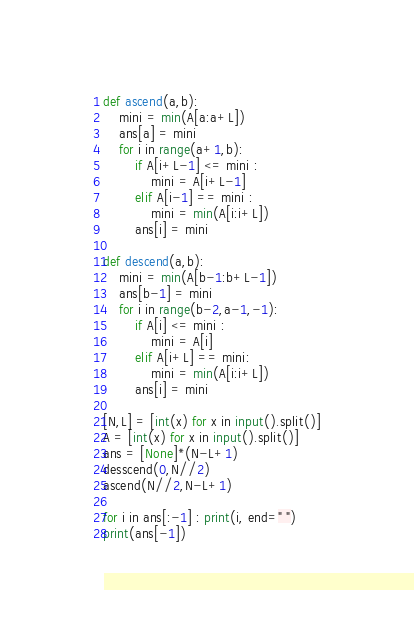<code> <loc_0><loc_0><loc_500><loc_500><_Python_>def ascend(a,b):
    mini = min(A[a:a+L])
    ans[a] = mini
    for i in range(a+1,b):
        if A[i+L-1] <= mini :
            mini = A[i+L-1]
        elif A[i-1] == mini :
            mini = min(A[i:i+L])
        ans[i] = mini

def descend(a,b):
    mini = min(A[b-1:b+L-1])
    ans[b-1] = mini
    for i in range(b-2,a-1,-1):
        if A[i] <= mini :
            mini = A[i]
        elif A[i+L] == mini:
            mini = min(A[i:i+L])
        ans[i] = mini
    
[N,L] = [int(x) for x in input().split()]
A = [int(x) for x in input().split()]
ans = [None]*(N-L+1)
desscend(0,N//2)
ascend(N//2,N-L+1)

for i in ans[:-1] : print(i, end=" ")
print(ans[-1])</code> 